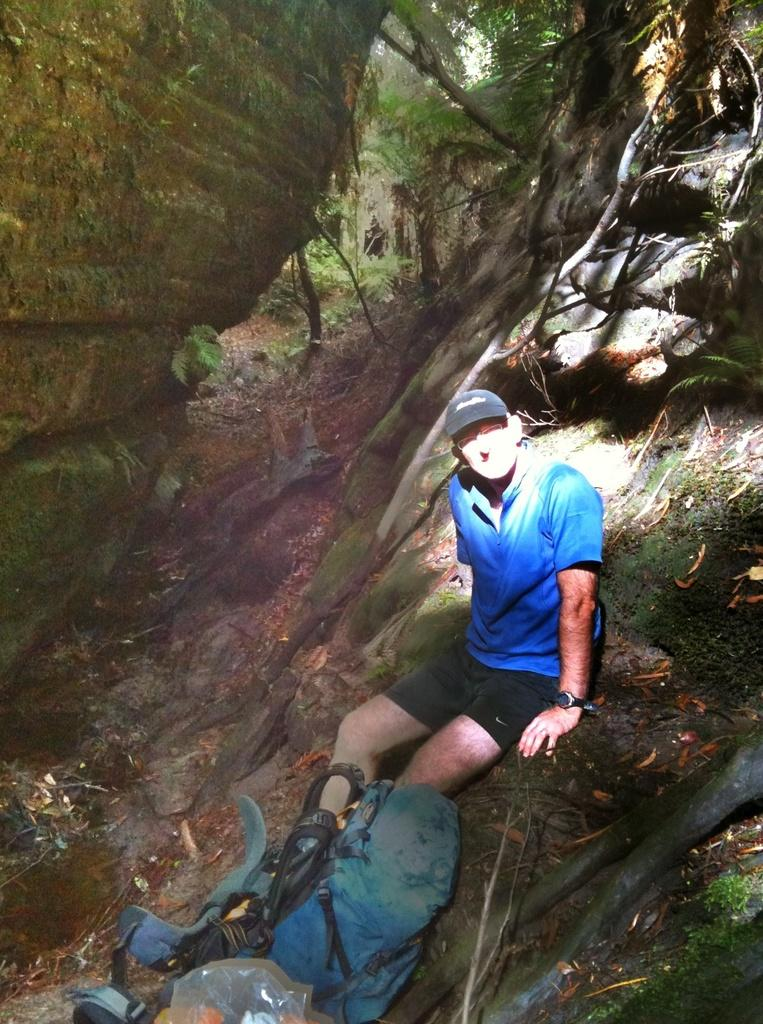What is the person in the image doing? There is a person sitting on a surface in the image. What else can be seen in the image besides the person? There are a few objects in the image. What can be seen in the distance in the image? Mountains and trees are visible in the background of the image. What type of stamp is the person holding in the image? There is no stamp present in the image; the person is simply sitting on a surface. 